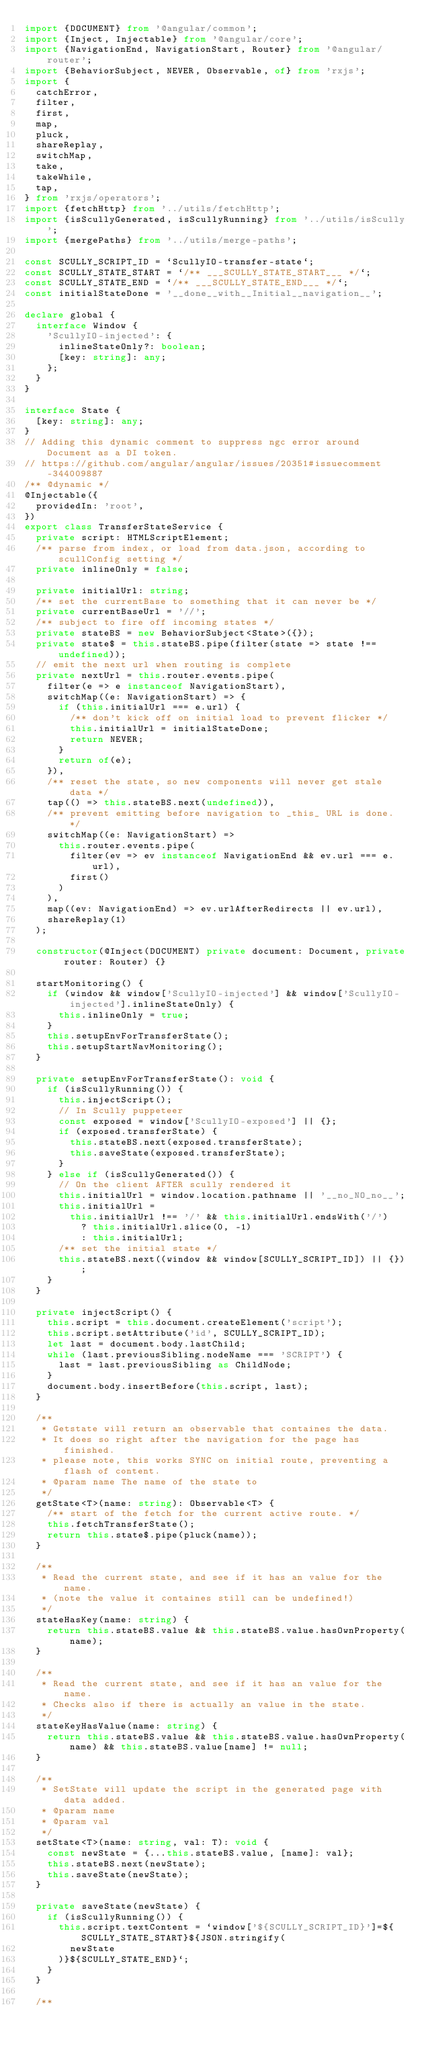Convert code to text. <code><loc_0><loc_0><loc_500><loc_500><_TypeScript_>import {DOCUMENT} from '@angular/common';
import {Inject, Injectable} from '@angular/core';
import {NavigationEnd, NavigationStart, Router} from '@angular/router';
import {BehaviorSubject, NEVER, Observable, of} from 'rxjs';
import {
  catchError,
  filter,
  first,
  map,
  pluck,
  shareReplay,
  switchMap,
  take,
  takeWhile,
  tap,
} from 'rxjs/operators';
import {fetchHttp} from '../utils/fetchHttp';
import {isScullyGenerated, isScullyRunning} from '../utils/isScully';
import {mergePaths} from '../utils/merge-paths';

const SCULLY_SCRIPT_ID = `ScullyIO-transfer-state`;
const SCULLY_STATE_START = `/** ___SCULLY_STATE_START___ */`;
const SCULLY_STATE_END = `/** ___SCULLY_STATE_END___ */`;
const initialStateDone = '__done__with__Initial__navigation__';

declare global {
  interface Window {
    'ScullyIO-injected': {
      inlineStateOnly?: boolean;
      [key: string]: any;
    };
  }
}

interface State {
  [key: string]: any;
}
// Adding this dynamic comment to suppress ngc error around Document as a DI token.
// https://github.com/angular/angular/issues/20351#issuecomment-344009887
/** @dynamic */
@Injectable({
  providedIn: 'root',
})
export class TransferStateService {
  private script: HTMLScriptElement;
  /** parse from index, or load from data.json, according to scullConfig setting */
  private inlineOnly = false;

  private initialUrl: string;
  /** set the currentBase to something that it can never be */
  private currentBaseUrl = '//';
  /** subject to fire off incoming states */
  private stateBS = new BehaviorSubject<State>({});
  private state$ = this.stateBS.pipe(filter(state => state !== undefined));
  // emit the next url when routing is complete
  private nextUrl = this.router.events.pipe(
    filter(e => e instanceof NavigationStart),
    switchMap((e: NavigationStart) => {
      if (this.initialUrl === e.url) {
        /** don't kick off on initial load to prevent flicker */
        this.initialUrl = initialStateDone;
        return NEVER;
      }
      return of(e);
    }),
    /** reset the state, so new components will never get stale data */
    tap(() => this.stateBS.next(undefined)),
    /** prevent emitting before navigation to _this_ URL is done. */
    switchMap((e: NavigationStart) =>
      this.router.events.pipe(
        filter(ev => ev instanceof NavigationEnd && ev.url === e.url),
        first()
      )
    ),
    map((ev: NavigationEnd) => ev.urlAfterRedirects || ev.url),
    shareReplay(1)
  );

  constructor(@Inject(DOCUMENT) private document: Document, private router: Router) {}

  startMonitoring() {
    if (window && window['ScullyIO-injected'] && window['ScullyIO-injected'].inlineStateOnly) {
      this.inlineOnly = true;
    }
    this.setupEnvForTransferState();
    this.setupStartNavMonitoring();
  }

  private setupEnvForTransferState(): void {
    if (isScullyRunning()) {
      this.injectScript();
      // In Scully puppeteer
      const exposed = window['ScullyIO-exposed'] || {};
      if (exposed.transferState) {
        this.stateBS.next(exposed.transferState);
        this.saveState(exposed.transferState);
      }
    } else if (isScullyGenerated()) {
      // On the client AFTER scully rendered it
      this.initialUrl = window.location.pathname || '__no_NO_no__';
      this.initialUrl =
        this.initialUrl !== '/' && this.initialUrl.endsWith('/')
          ? this.initialUrl.slice(0, -1)
          : this.initialUrl;
      /** set the initial state */
      this.stateBS.next((window && window[SCULLY_SCRIPT_ID]) || {});
    }
  }

  private injectScript() {
    this.script = this.document.createElement('script');
    this.script.setAttribute('id', SCULLY_SCRIPT_ID);
    let last = document.body.lastChild;
    while (last.previousSibling.nodeName === 'SCRIPT') {
      last = last.previousSibling as ChildNode;
    }
    document.body.insertBefore(this.script, last);
  }

  /**
   * Getstate will return an observable that containes the data.
   * It does so right after the navigation for the page has finished.
   * please note, this works SYNC on initial route, preventing a flash of content.
   * @param name The name of the state to
   */
  getState<T>(name: string): Observable<T> {
    /** start of the fetch for the current active route. */
    this.fetchTransferState();
    return this.state$.pipe(pluck(name));
  }

  /**
   * Read the current state, and see if it has an value for the name.
   * (note the value it containes still can be undefined!)
   */
  stateHasKey(name: string) {
    return this.stateBS.value && this.stateBS.value.hasOwnProperty(name);
  }

  /**
   * Read the current state, and see if it has an value for the name.
   * Checks also if there is actually an value in the state.
   */
  stateKeyHasValue(name: string) {
    return this.stateBS.value && this.stateBS.value.hasOwnProperty(name) && this.stateBS.value[name] != null;
  }

  /**
   * SetState will update the script in the generated page with data added.
   * @param name
   * @param val
   */
  setState<T>(name: string, val: T): void {
    const newState = {...this.stateBS.value, [name]: val};
    this.stateBS.next(newState);
    this.saveState(newState);
  }

  private saveState(newState) {
    if (isScullyRunning()) {
      this.script.textContent = `window['${SCULLY_SCRIPT_ID}']=${SCULLY_STATE_START}${JSON.stringify(
        newState
      )}${SCULLY_STATE_END}`;
    }
  }

  /**</code> 